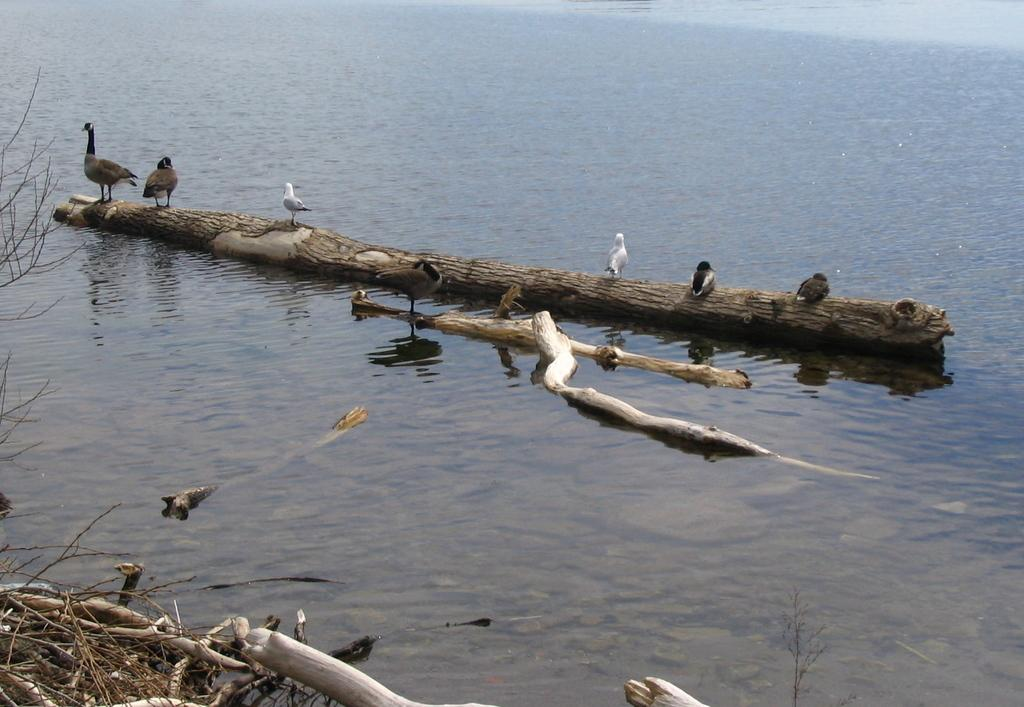What animals are on the wooden log in the image? There are birds on a wooden log in the image. What is the wooden log floating on? The wooden log is floating on water. What other wooden objects can be seen in the image? There are wooden sticks visible in the image. What scientific discovery is being made on the island in the image? There is no island present in the image, and no scientific discovery is being made. 